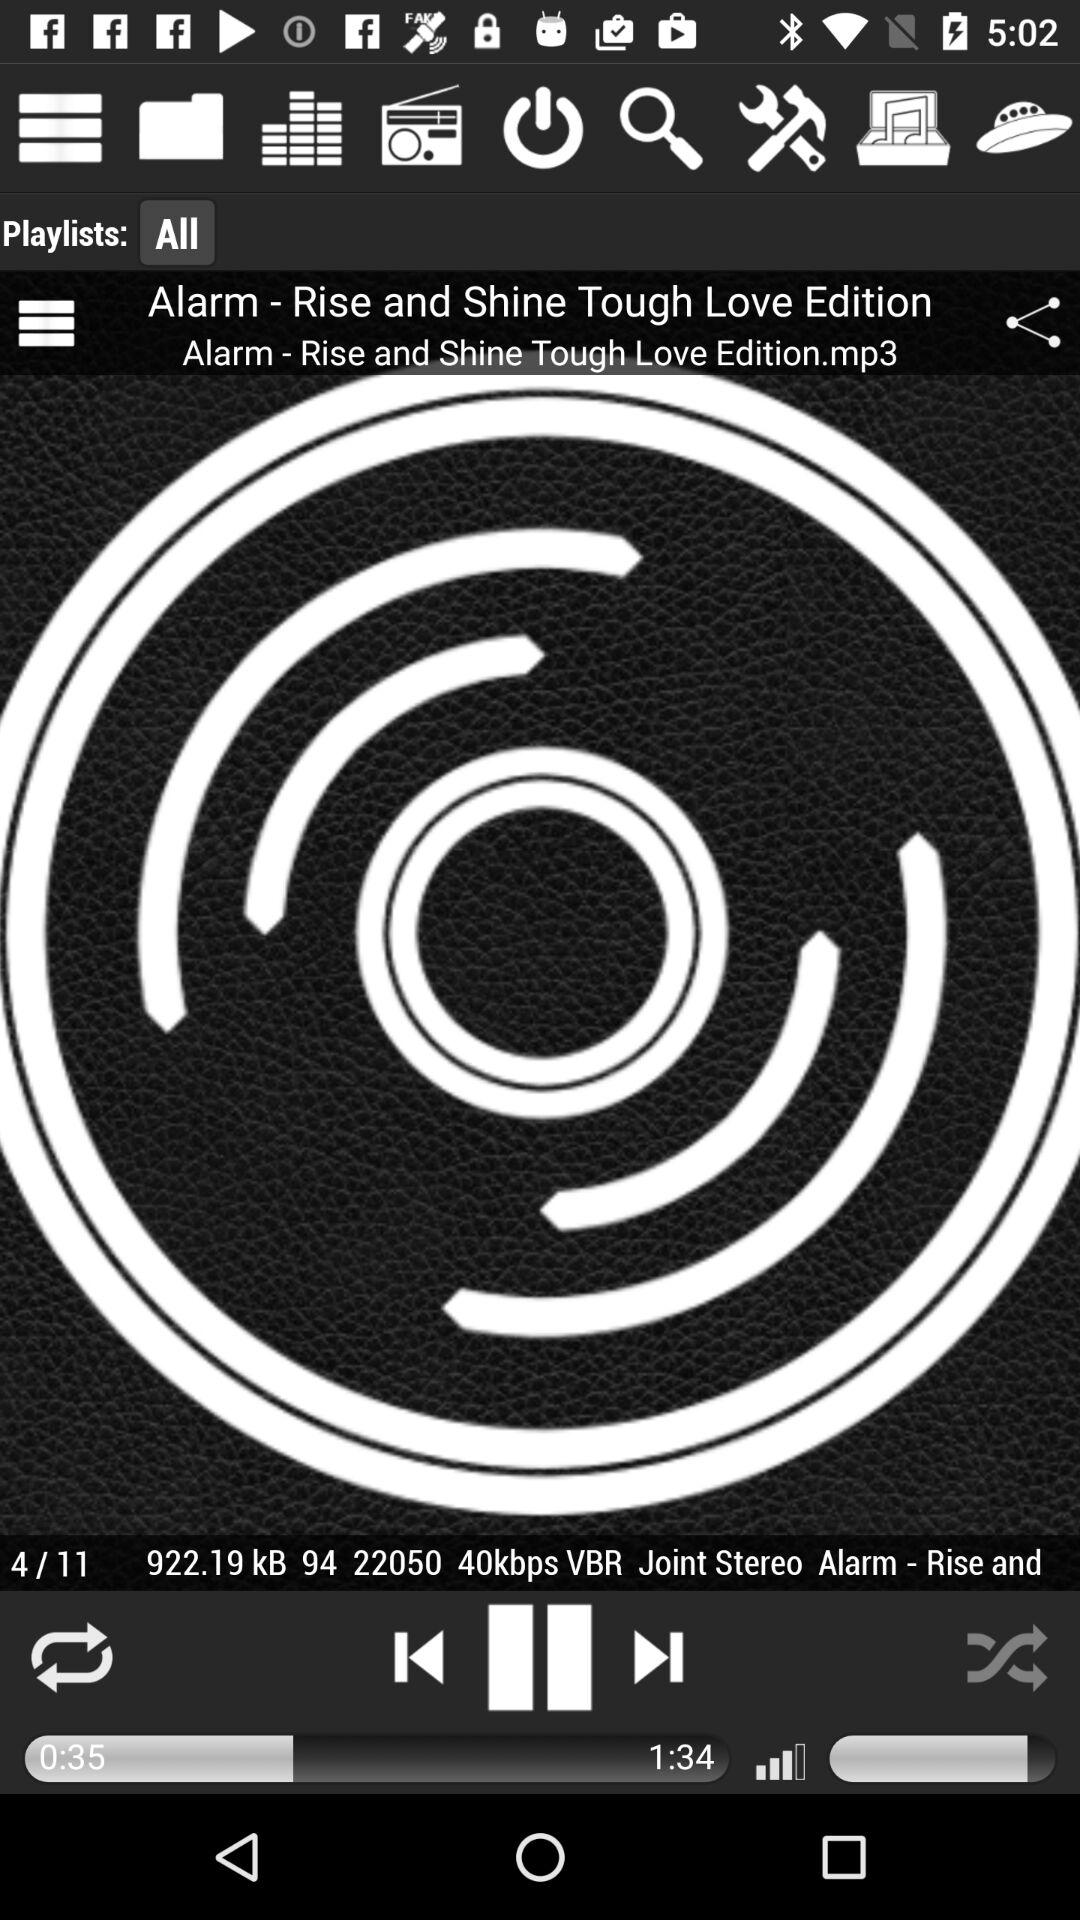Which audio number is currently being played? The audio number currently being played is 4. 